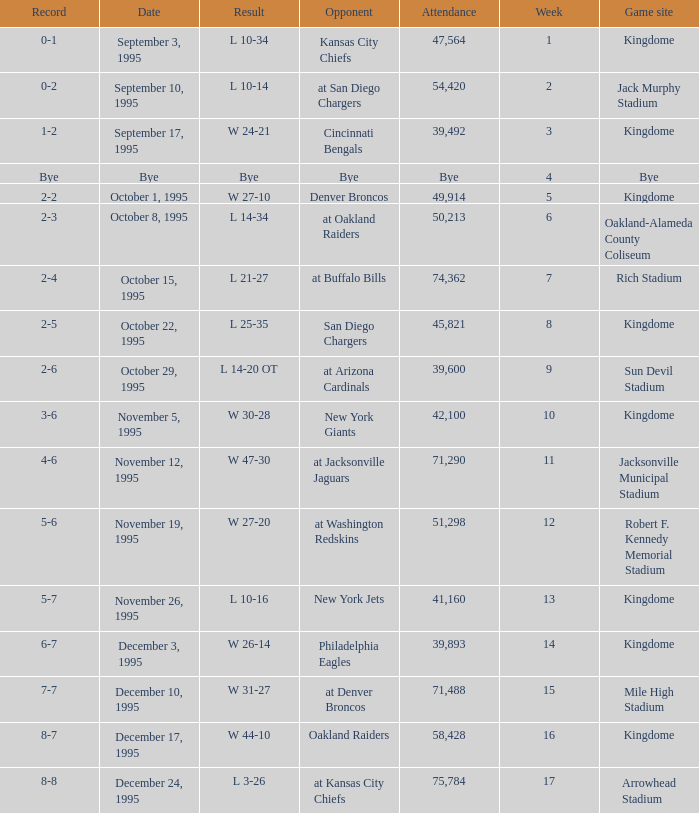Who were the competitors when the seattle seahawks achieved an 8-7 record? Oakland Raiders. 